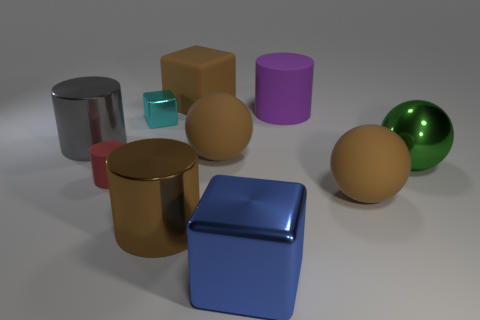Subtract 1 cylinders. How many cylinders are left? 3 Subtract all cubes. How many objects are left? 7 Add 8 gray cylinders. How many gray cylinders are left? 9 Add 2 matte things. How many matte things exist? 7 Subtract 0 green cylinders. How many objects are left? 10 Subtract all gray metal blocks. Subtract all tiny red matte cylinders. How many objects are left? 9 